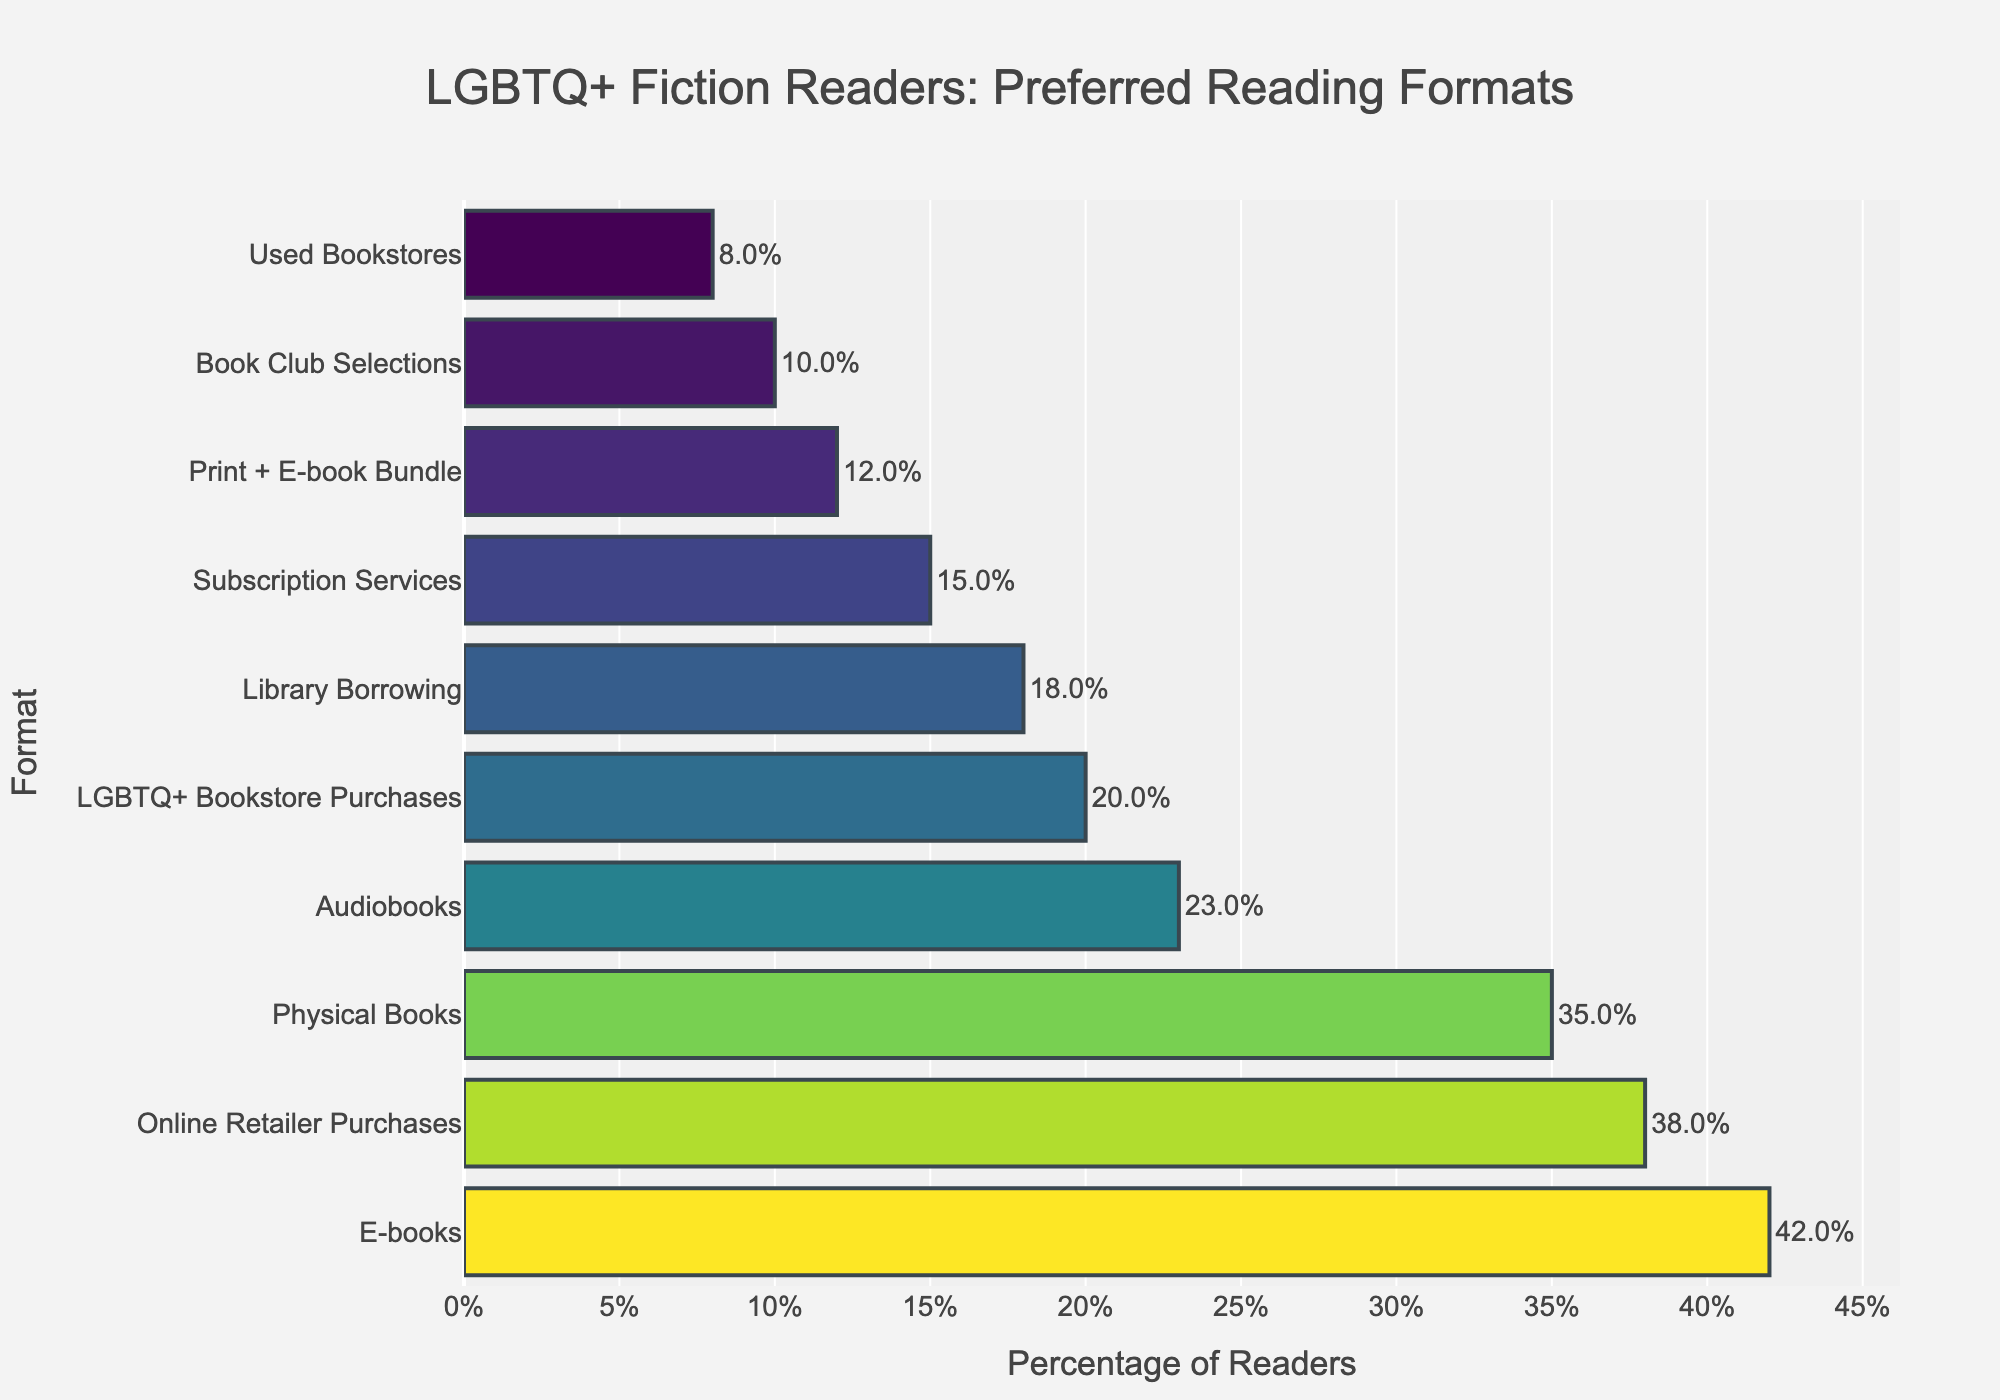Which reading format is the most preferred by LGBTQ+ fiction readers? The bar representing e-books has the highest percentage at 42%.
Answer: E-books What is the difference in percentage between readers who prefer physical books and those who prefer audiobooks? The percentage for physical books is 35%, and for audiobooks, it is 23%. The difference is 35% - 23% = 12%.
Answer: 12% How many formats have a preference percentage greater than 20%? From the bar chart, the formats with more than 20% preference are e-books (42%), physical books (35%), online retailer purchases (38%), and LGBTQ+ bookstore purchases (20%).
Answer: 4 Between library borrowing and subscription services, which one has a higher preference percentage and by how much? Library borrowing is at 18%, and subscription services are at 15%. The difference is 18% - 15% = 3%.
Answer: Library borrowing by 3% What's the sum of percentages of the least and the most preferred formats? The least preferred format is used bookstores (8%), and the most preferred is e-books (42%). The sum is 8% + 42% = 50%.
Answer: 50% Which format shows exactly half the preference percentage of online retailer purchases? Online retailer purchases are at 38%. Half of this is 38% / 2 = 19%. None of the formats show exactly 19%, but the closest is LGBTQ+ bookstore purchases at 20%.
Answer: None exactly, but LGBTQ+ bookstore purchases is closest at 20% Do more readers prefer book club selections or print + e-book bundle, and by what percentage? Print + e-book bundles have 12%, and book club selections have 10%. The difference is 12% - 10% = 2%.
Answer: Print + e-book bundle by 2% Which format shows a lower preference than print + e-book bundle and by how much? Print + e-book bundle is at 12%, and the format with lower preference is used bookstores at 8%. The difference is 12% - 8% = 4%.
Answer: Used bookstores by 4% What is the average preference percentage for the top three preferred formats? The top three preferred formats are e-books (42%), physical books (35%), and online retailer purchases (38%). The average is (42% + 35% + 38%) / 3 = 115% / 3 = 38.33%.
Answer: 38.33% 